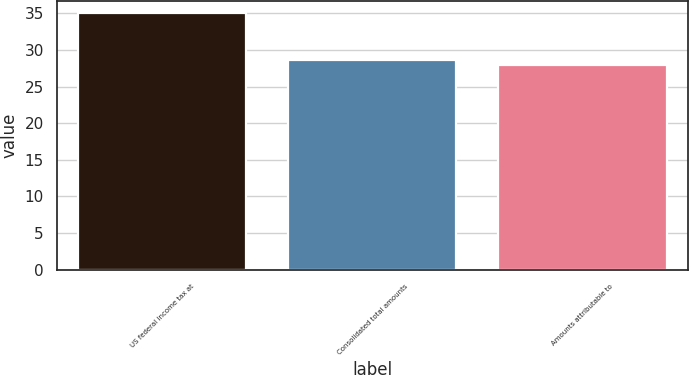Convert chart. <chart><loc_0><loc_0><loc_500><loc_500><bar_chart><fcel>US federal income tax at<fcel>Consolidated total amounts<fcel>Amounts attributable to<nl><fcel>35<fcel>28.61<fcel>27.9<nl></chart> 